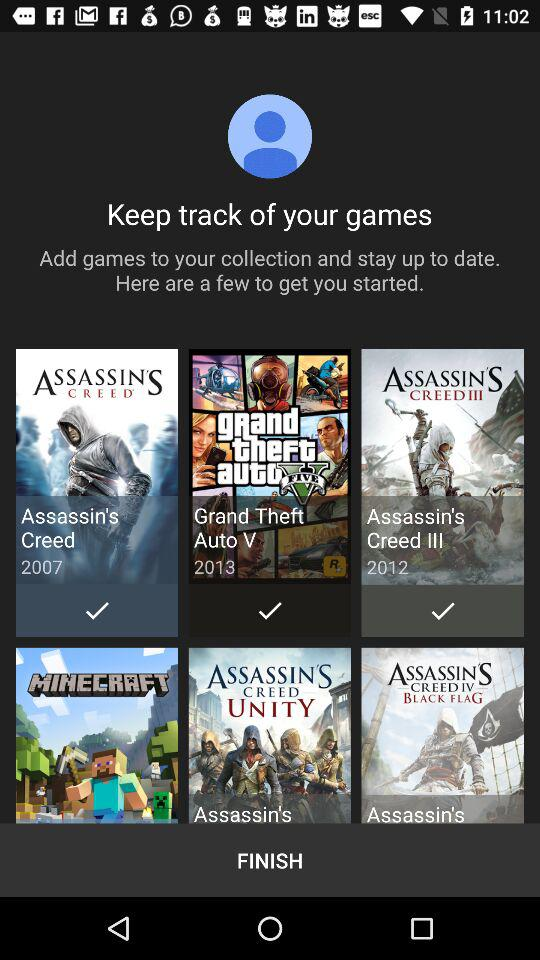What is the release year of "Grand theft auto V"? The release year is 2013. 